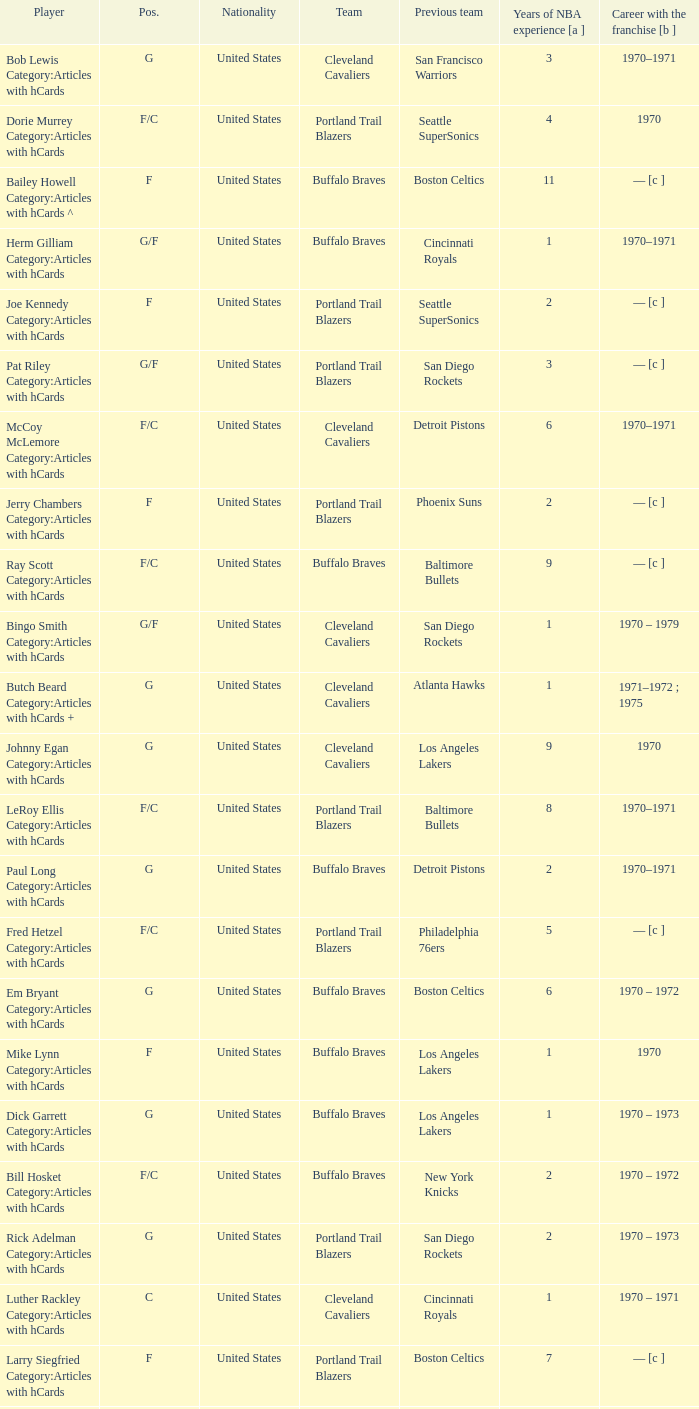Who is the player from the Buffalo Braves with the previous team Los Angeles Lakers and a career with the franchase in 1970? Mike Lynn Category:Articles with hCards. 